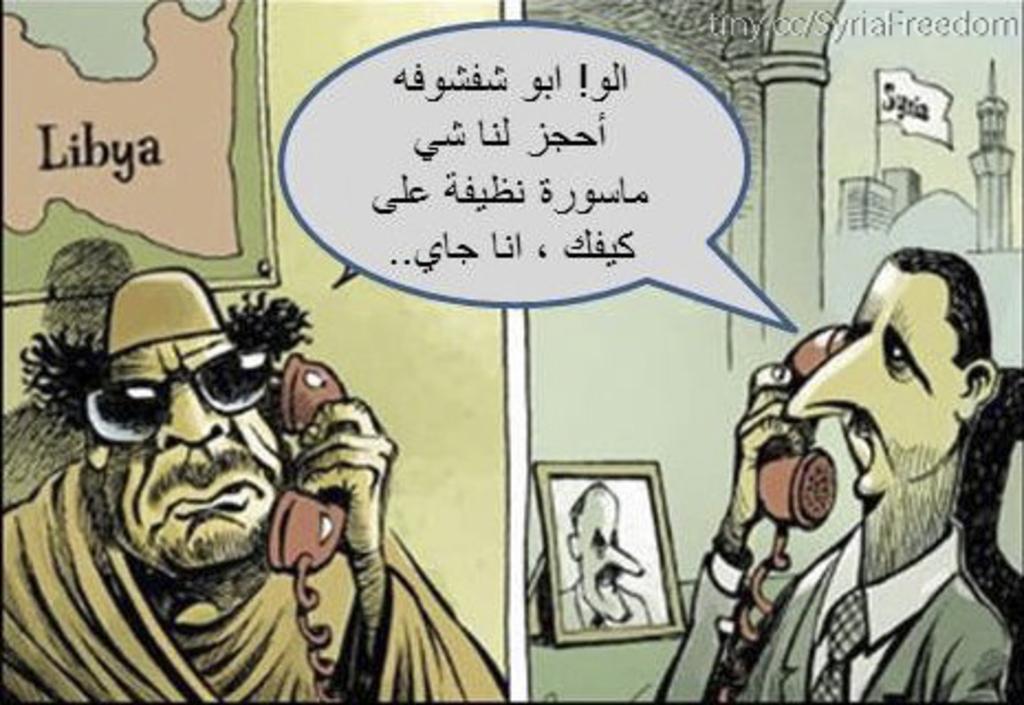Could you give a brief overview of what you see in this image? In the image we can see there is a cartoon animation picture and there is a collage of pictures in which there are men standing and they are holding telephone wire. Behind on the wall there are banners kept on the wall on which there are buildings and there is a map and its written ¨Libya¨. There is a photo frame kept on the table and there is a message pop up. 